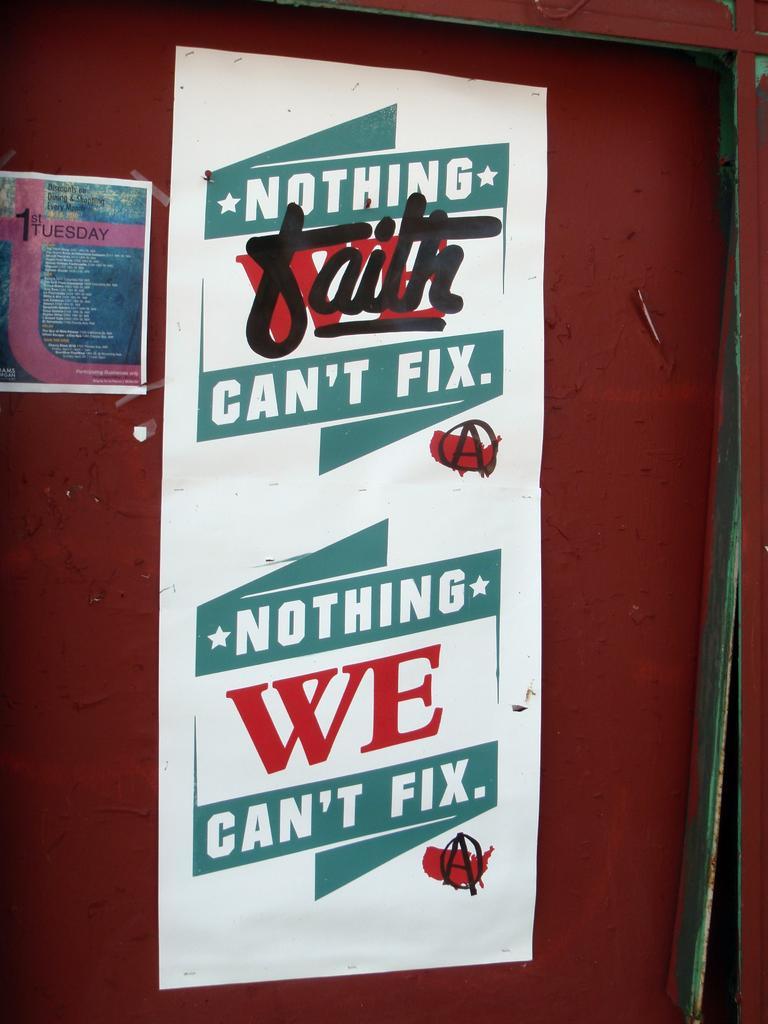Can you describe this image briefly? In this image I can see the brown colored surface and to it I can see two posts are attached. 